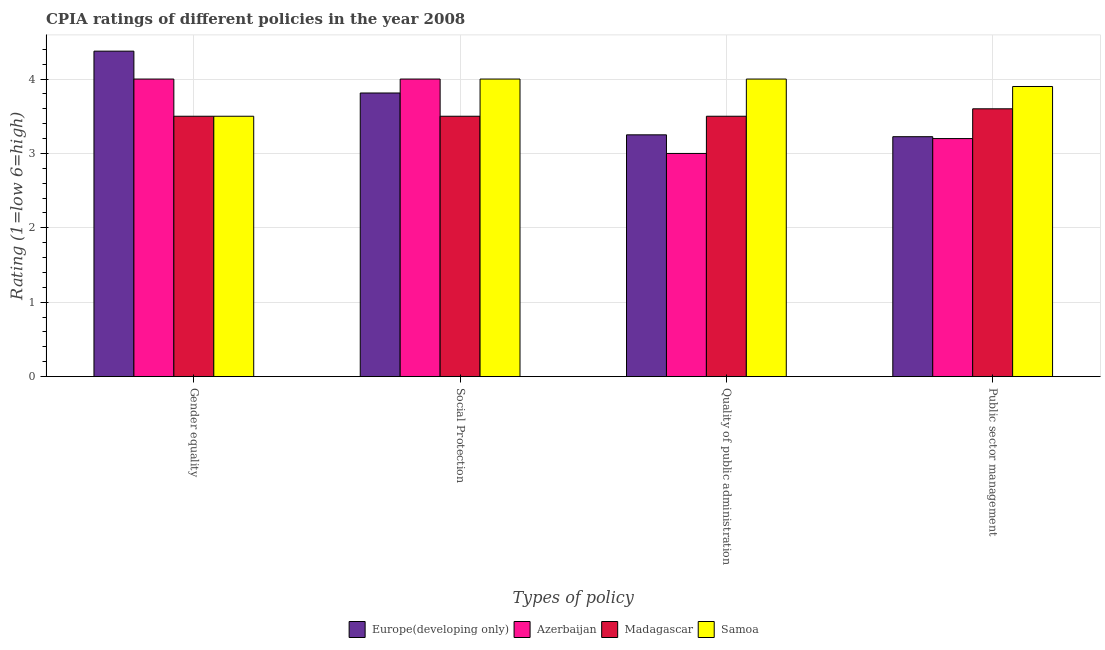How many groups of bars are there?
Your answer should be very brief. 4. Are the number of bars per tick equal to the number of legend labels?
Your response must be concise. Yes. How many bars are there on the 3rd tick from the left?
Provide a succinct answer. 4. What is the label of the 2nd group of bars from the left?
Your answer should be compact. Social Protection. What is the cpia rating of public sector management in Madagascar?
Your answer should be compact. 3.6. Across all countries, what is the maximum cpia rating of gender equality?
Offer a very short reply. 4.38. In which country was the cpia rating of public sector management maximum?
Provide a succinct answer. Samoa. In which country was the cpia rating of social protection minimum?
Offer a very short reply. Madagascar. What is the total cpia rating of social protection in the graph?
Your answer should be very brief. 15.31. What is the difference between the cpia rating of gender equality in Madagascar and the cpia rating of quality of public administration in Europe(developing only)?
Your response must be concise. 0.25. What is the average cpia rating of gender equality per country?
Make the answer very short. 3.84. What is the ratio of the cpia rating of gender equality in Azerbaijan to that in Samoa?
Provide a succinct answer. 1.14. Is the cpia rating of quality of public administration in Europe(developing only) less than that in Azerbaijan?
Give a very brief answer. No. What is the difference between the highest and the second highest cpia rating of public sector management?
Your response must be concise. 0.3. What is the difference between the highest and the lowest cpia rating of public sector management?
Make the answer very short. 0.7. In how many countries, is the cpia rating of quality of public administration greater than the average cpia rating of quality of public administration taken over all countries?
Your answer should be compact. 2. Is the sum of the cpia rating of gender equality in Samoa and Europe(developing only) greater than the maximum cpia rating of social protection across all countries?
Your response must be concise. Yes. What does the 4th bar from the left in Public sector management represents?
Provide a short and direct response. Samoa. What does the 3rd bar from the right in Gender equality represents?
Your answer should be very brief. Azerbaijan. Is it the case that in every country, the sum of the cpia rating of gender equality and cpia rating of social protection is greater than the cpia rating of quality of public administration?
Offer a terse response. Yes. Are all the bars in the graph horizontal?
Offer a terse response. No. How many countries are there in the graph?
Offer a terse response. 4. What is the difference between two consecutive major ticks on the Y-axis?
Give a very brief answer. 1. Are the values on the major ticks of Y-axis written in scientific E-notation?
Ensure brevity in your answer.  No. Where does the legend appear in the graph?
Your answer should be compact. Bottom center. How many legend labels are there?
Keep it short and to the point. 4. What is the title of the graph?
Your answer should be very brief. CPIA ratings of different policies in the year 2008. Does "Croatia" appear as one of the legend labels in the graph?
Keep it short and to the point. No. What is the label or title of the X-axis?
Give a very brief answer. Types of policy. What is the Rating (1=low 6=high) in Europe(developing only) in Gender equality?
Your response must be concise. 4.38. What is the Rating (1=low 6=high) of Europe(developing only) in Social Protection?
Offer a terse response. 3.81. What is the Rating (1=low 6=high) of Madagascar in Social Protection?
Provide a short and direct response. 3.5. What is the Rating (1=low 6=high) in Madagascar in Quality of public administration?
Your response must be concise. 3.5. What is the Rating (1=low 6=high) of Samoa in Quality of public administration?
Offer a very short reply. 4. What is the Rating (1=low 6=high) in Europe(developing only) in Public sector management?
Your response must be concise. 3.23. What is the Rating (1=low 6=high) in Madagascar in Public sector management?
Provide a succinct answer. 3.6. Across all Types of policy, what is the maximum Rating (1=low 6=high) in Europe(developing only)?
Provide a succinct answer. 4.38. Across all Types of policy, what is the maximum Rating (1=low 6=high) in Azerbaijan?
Give a very brief answer. 4. Across all Types of policy, what is the minimum Rating (1=low 6=high) in Europe(developing only)?
Your answer should be very brief. 3.23. Across all Types of policy, what is the minimum Rating (1=low 6=high) of Azerbaijan?
Provide a short and direct response. 3. What is the total Rating (1=low 6=high) of Europe(developing only) in the graph?
Your answer should be compact. 14.66. What is the difference between the Rating (1=low 6=high) of Europe(developing only) in Gender equality and that in Social Protection?
Keep it short and to the point. 0.56. What is the difference between the Rating (1=low 6=high) in Madagascar in Gender equality and that in Social Protection?
Provide a succinct answer. 0. What is the difference between the Rating (1=low 6=high) in Samoa in Gender equality and that in Social Protection?
Keep it short and to the point. -0.5. What is the difference between the Rating (1=low 6=high) of Europe(developing only) in Gender equality and that in Quality of public administration?
Provide a succinct answer. 1.12. What is the difference between the Rating (1=low 6=high) in Madagascar in Gender equality and that in Quality of public administration?
Offer a very short reply. 0. What is the difference between the Rating (1=low 6=high) in Samoa in Gender equality and that in Quality of public administration?
Ensure brevity in your answer.  -0.5. What is the difference between the Rating (1=low 6=high) in Europe(developing only) in Gender equality and that in Public sector management?
Provide a succinct answer. 1.15. What is the difference between the Rating (1=low 6=high) in Europe(developing only) in Social Protection and that in Quality of public administration?
Keep it short and to the point. 0.56. What is the difference between the Rating (1=low 6=high) in Azerbaijan in Social Protection and that in Quality of public administration?
Your answer should be very brief. 1. What is the difference between the Rating (1=low 6=high) of Samoa in Social Protection and that in Quality of public administration?
Ensure brevity in your answer.  0. What is the difference between the Rating (1=low 6=high) in Europe(developing only) in Social Protection and that in Public sector management?
Ensure brevity in your answer.  0.59. What is the difference between the Rating (1=low 6=high) in Azerbaijan in Social Protection and that in Public sector management?
Keep it short and to the point. 0.8. What is the difference between the Rating (1=low 6=high) in Europe(developing only) in Quality of public administration and that in Public sector management?
Your answer should be very brief. 0.03. What is the difference between the Rating (1=low 6=high) in Samoa in Quality of public administration and that in Public sector management?
Your response must be concise. 0.1. What is the difference between the Rating (1=low 6=high) in Europe(developing only) in Gender equality and the Rating (1=low 6=high) in Azerbaijan in Social Protection?
Your answer should be compact. 0.38. What is the difference between the Rating (1=low 6=high) of Europe(developing only) in Gender equality and the Rating (1=low 6=high) of Madagascar in Social Protection?
Your response must be concise. 0.88. What is the difference between the Rating (1=low 6=high) of Europe(developing only) in Gender equality and the Rating (1=low 6=high) of Samoa in Social Protection?
Make the answer very short. 0.38. What is the difference between the Rating (1=low 6=high) in Madagascar in Gender equality and the Rating (1=low 6=high) in Samoa in Social Protection?
Provide a succinct answer. -0.5. What is the difference between the Rating (1=low 6=high) in Europe(developing only) in Gender equality and the Rating (1=low 6=high) in Azerbaijan in Quality of public administration?
Provide a short and direct response. 1.38. What is the difference between the Rating (1=low 6=high) in Europe(developing only) in Gender equality and the Rating (1=low 6=high) in Samoa in Quality of public administration?
Your response must be concise. 0.38. What is the difference between the Rating (1=low 6=high) in Azerbaijan in Gender equality and the Rating (1=low 6=high) in Madagascar in Quality of public administration?
Your answer should be compact. 0.5. What is the difference between the Rating (1=low 6=high) of Azerbaijan in Gender equality and the Rating (1=low 6=high) of Samoa in Quality of public administration?
Your response must be concise. 0. What is the difference between the Rating (1=low 6=high) in Europe(developing only) in Gender equality and the Rating (1=low 6=high) in Azerbaijan in Public sector management?
Your response must be concise. 1.18. What is the difference between the Rating (1=low 6=high) of Europe(developing only) in Gender equality and the Rating (1=low 6=high) of Madagascar in Public sector management?
Your response must be concise. 0.78. What is the difference between the Rating (1=low 6=high) of Europe(developing only) in Gender equality and the Rating (1=low 6=high) of Samoa in Public sector management?
Offer a very short reply. 0.47. What is the difference between the Rating (1=low 6=high) in Madagascar in Gender equality and the Rating (1=low 6=high) in Samoa in Public sector management?
Make the answer very short. -0.4. What is the difference between the Rating (1=low 6=high) in Europe(developing only) in Social Protection and the Rating (1=low 6=high) in Azerbaijan in Quality of public administration?
Make the answer very short. 0.81. What is the difference between the Rating (1=low 6=high) of Europe(developing only) in Social Protection and the Rating (1=low 6=high) of Madagascar in Quality of public administration?
Provide a succinct answer. 0.31. What is the difference between the Rating (1=low 6=high) of Europe(developing only) in Social Protection and the Rating (1=low 6=high) of Samoa in Quality of public administration?
Your answer should be compact. -0.19. What is the difference between the Rating (1=low 6=high) of Europe(developing only) in Social Protection and the Rating (1=low 6=high) of Azerbaijan in Public sector management?
Keep it short and to the point. 0.61. What is the difference between the Rating (1=low 6=high) of Europe(developing only) in Social Protection and the Rating (1=low 6=high) of Madagascar in Public sector management?
Your answer should be very brief. 0.21. What is the difference between the Rating (1=low 6=high) of Europe(developing only) in Social Protection and the Rating (1=low 6=high) of Samoa in Public sector management?
Your response must be concise. -0.09. What is the difference between the Rating (1=low 6=high) of Azerbaijan in Social Protection and the Rating (1=low 6=high) of Madagascar in Public sector management?
Your answer should be compact. 0.4. What is the difference between the Rating (1=low 6=high) in Azerbaijan in Social Protection and the Rating (1=low 6=high) in Samoa in Public sector management?
Make the answer very short. 0.1. What is the difference between the Rating (1=low 6=high) in Europe(developing only) in Quality of public administration and the Rating (1=low 6=high) in Madagascar in Public sector management?
Offer a very short reply. -0.35. What is the difference between the Rating (1=low 6=high) of Europe(developing only) in Quality of public administration and the Rating (1=low 6=high) of Samoa in Public sector management?
Provide a succinct answer. -0.65. What is the difference between the Rating (1=low 6=high) of Azerbaijan in Quality of public administration and the Rating (1=low 6=high) of Madagascar in Public sector management?
Provide a short and direct response. -0.6. What is the difference between the Rating (1=low 6=high) in Madagascar in Quality of public administration and the Rating (1=low 6=high) in Samoa in Public sector management?
Ensure brevity in your answer.  -0.4. What is the average Rating (1=low 6=high) of Europe(developing only) per Types of policy?
Provide a short and direct response. 3.67. What is the average Rating (1=low 6=high) of Azerbaijan per Types of policy?
Provide a short and direct response. 3.55. What is the average Rating (1=low 6=high) in Madagascar per Types of policy?
Your response must be concise. 3.52. What is the average Rating (1=low 6=high) of Samoa per Types of policy?
Your response must be concise. 3.85. What is the difference between the Rating (1=low 6=high) of Europe(developing only) and Rating (1=low 6=high) of Azerbaijan in Gender equality?
Keep it short and to the point. 0.38. What is the difference between the Rating (1=low 6=high) in Europe(developing only) and Rating (1=low 6=high) in Madagascar in Gender equality?
Provide a succinct answer. 0.88. What is the difference between the Rating (1=low 6=high) of Azerbaijan and Rating (1=low 6=high) of Madagascar in Gender equality?
Give a very brief answer. 0.5. What is the difference between the Rating (1=low 6=high) in Azerbaijan and Rating (1=low 6=high) in Samoa in Gender equality?
Ensure brevity in your answer.  0.5. What is the difference between the Rating (1=low 6=high) in Madagascar and Rating (1=low 6=high) in Samoa in Gender equality?
Ensure brevity in your answer.  0. What is the difference between the Rating (1=low 6=high) in Europe(developing only) and Rating (1=low 6=high) in Azerbaijan in Social Protection?
Provide a succinct answer. -0.19. What is the difference between the Rating (1=low 6=high) of Europe(developing only) and Rating (1=low 6=high) of Madagascar in Social Protection?
Provide a succinct answer. 0.31. What is the difference between the Rating (1=low 6=high) in Europe(developing only) and Rating (1=low 6=high) in Samoa in Social Protection?
Provide a short and direct response. -0.19. What is the difference between the Rating (1=low 6=high) of Azerbaijan and Rating (1=low 6=high) of Samoa in Social Protection?
Make the answer very short. 0. What is the difference between the Rating (1=low 6=high) in Madagascar and Rating (1=low 6=high) in Samoa in Social Protection?
Your answer should be very brief. -0.5. What is the difference between the Rating (1=low 6=high) in Europe(developing only) and Rating (1=low 6=high) in Azerbaijan in Quality of public administration?
Give a very brief answer. 0.25. What is the difference between the Rating (1=low 6=high) of Europe(developing only) and Rating (1=low 6=high) of Madagascar in Quality of public administration?
Offer a very short reply. -0.25. What is the difference between the Rating (1=low 6=high) of Europe(developing only) and Rating (1=low 6=high) of Samoa in Quality of public administration?
Ensure brevity in your answer.  -0.75. What is the difference between the Rating (1=low 6=high) of Azerbaijan and Rating (1=low 6=high) of Madagascar in Quality of public administration?
Offer a terse response. -0.5. What is the difference between the Rating (1=low 6=high) of Madagascar and Rating (1=low 6=high) of Samoa in Quality of public administration?
Keep it short and to the point. -0.5. What is the difference between the Rating (1=low 6=high) of Europe(developing only) and Rating (1=low 6=high) of Azerbaijan in Public sector management?
Keep it short and to the point. 0.03. What is the difference between the Rating (1=low 6=high) of Europe(developing only) and Rating (1=low 6=high) of Madagascar in Public sector management?
Ensure brevity in your answer.  -0.38. What is the difference between the Rating (1=low 6=high) of Europe(developing only) and Rating (1=low 6=high) of Samoa in Public sector management?
Your answer should be very brief. -0.68. What is the difference between the Rating (1=low 6=high) of Madagascar and Rating (1=low 6=high) of Samoa in Public sector management?
Ensure brevity in your answer.  -0.3. What is the ratio of the Rating (1=low 6=high) of Europe(developing only) in Gender equality to that in Social Protection?
Ensure brevity in your answer.  1.15. What is the ratio of the Rating (1=low 6=high) of Madagascar in Gender equality to that in Social Protection?
Keep it short and to the point. 1. What is the ratio of the Rating (1=low 6=high) in Samoa in Gender equality to that in Social Protection?
Give a very brief answer. 0.88. What is the ratio of the Rating (1=low 6=high) in Europe(developing only) in Gender equality to that in Quality of public administration?
Ensure brevity in your answer.  1.35. What is the ratio of the Rating (1=low 6=high) of Azerbaijan in Gender equality to that in Quality of public administration?
Offer a terse response. 1.33. What is the ratio of the Rating (1=low 6=high) of Madagascar in Gender equality to that in Quality of public administration?
Offer a terse response. 1. What is the ratio of the Rating (1=low 6=high) of Europe(developing only) in Gender equality to that in Public sector management?
Keep it short and to the point. 1.36. What is the ratio of the Rating (1=low 6=high) of Azerbaijan in Gender equality to that in Public sector management?
Ensure brevity in your answer.  1.25. What is the ratio of the Rating (1=low 6=high) in Madagascar in Gender equality to that in Public sector management?
Your answer should be compact. 0.97. What is the ratio of the Rating (1=low 6=high) of Samoa in Gender equality to that in Public sector management?
Your answer should be compact. 0.9. What is the ratio of the Rating (1=low 6=high) of Europe(developing only) in Social Protection to that in Quality of public administration?
Ensure brevity in your answer.  1.17. What is the ratio of the Rating (1=low 6=high) in Azerbaijan in Social Protection to that in Quality of public administration?
Provide a succinct answer. 1.33. What is the ratio of the Rating (1=low 6=high) of Madagascar in Social Protection to that in Quality of public administration?
Offer a very short reply. 1. What is the ratio of the Rating (1=low 6=high) of Samoa in Social Protection to that in Quality of public administration?
Your answer should be very brief. 1. What is the ratio of the Rating (1=low 6=high) in Europe(developing only) in Social Protection to that in Public sector management?
Keep it short and to the point. 1.18. What is the ratio of the Rating (1=low 6=high) of Azerbaijan in Social Protection to that in Public sector management?
Give a very brief answer. 1.25. What is the ratio of the Rating (1=low 6=high) in Madagascar in Social Protection to that in Public sector management?
Offer a terse response. 0.97. What is the ratio of the Rating (1=low 6=high) of Samoa in Social Protection to that in Public sector management?
Provide a succinct answer. 1.03. What is the ratio of the Rating (1=low 6=high) of Madagascar in Quality of public administration to that in Public sector management?
Your answer should be very brief. 0.97. What is the ratio of the Rating (1=low 6=high) of Samoa in Quality of public administration to that in Public sector management?
Ensure brevity in your answer.  1.03. What is the difference between the highest and the second highest Rating (1=low 6=high) in Europe(developing only)?
Give a very brief answer. 0.56. What is the difference between the highest and the second highest Rating (1=low 6=high) of Samoa?
Offer a terse response. 0. What is the difference between the highest and the lowest Rating (1=low 6=high) of Europe(developing only)?
Your answer should be very brief. 1.15. 